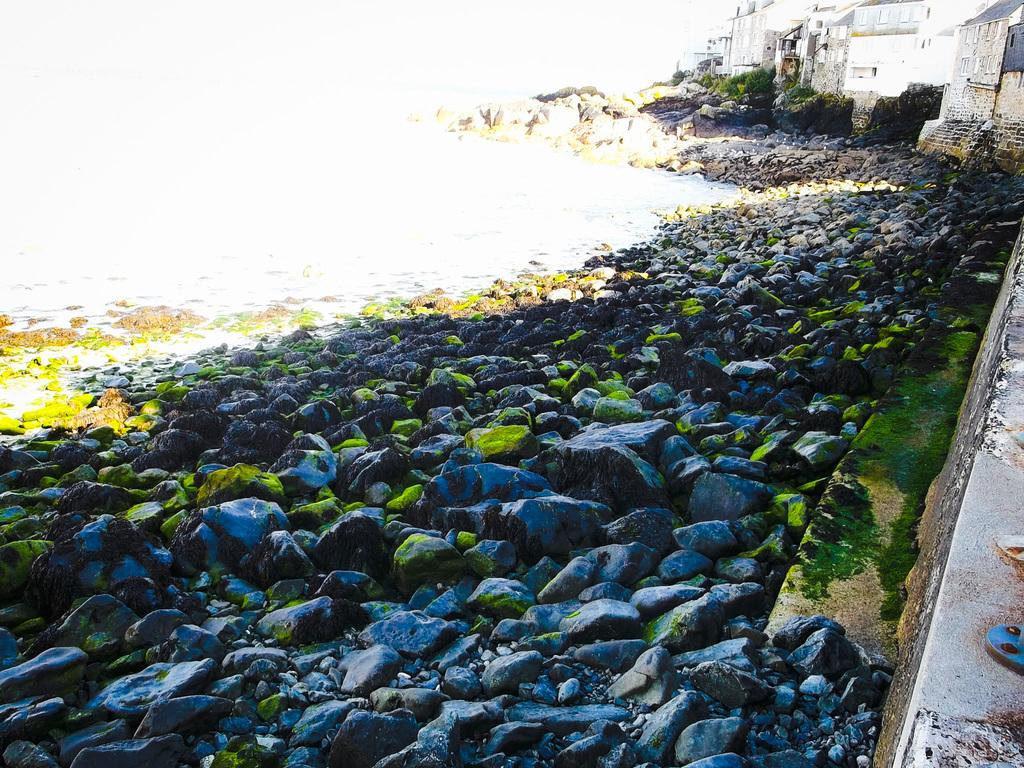What can be seen in the top right side of the image? There are houses and greenery in the top right side of the image. What is present at the bottom side of the image? There are pebbles and algae at the bottom side of the image. What color is the crayon used to draw the houses in the image? There is no crayon present in the image; the houses are depicted using photographic or digital means. What type of test is being conducted in the image? There is no test being conducted in the image; it features houses, greenery, pebbles, and algae. 